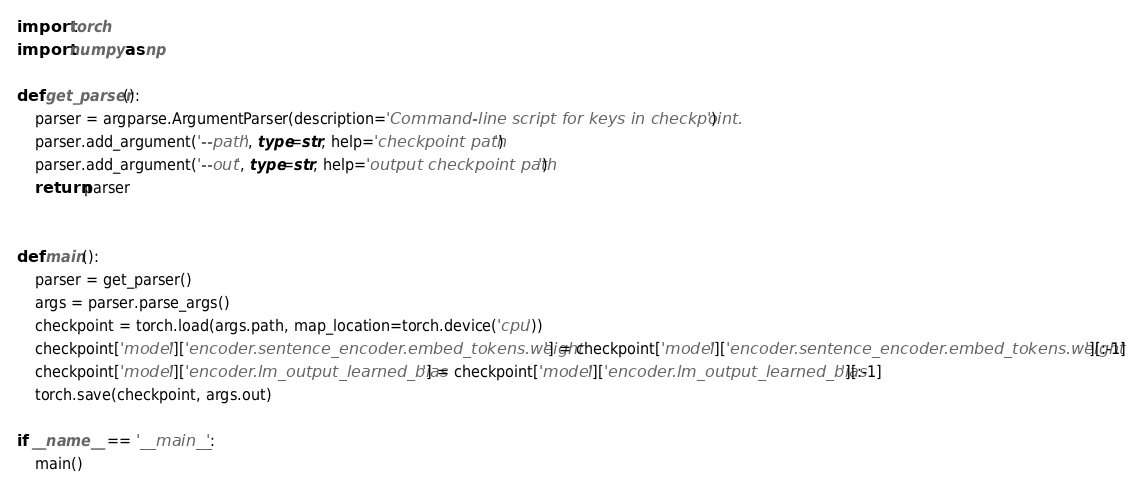Convert code to text. <code><loc_0><loc_0><loc_500><loc_500><_Python_>import torch 
import numpy as np

def get_parser():
    parser = argparse.ArgumentParser(description='Command-line script for keys in checkpoint.')
    parser.add_argument('--path', type=str, help='checkpoint path')
    parser.add_argument('--out', type=str, help='output checkpoint path')
    return parser


def main():
    parser = get_parser()
    args = parser.parse_args()
    checkpoint = torch.load(args.path, map_location=torch.device('cpu'))
    checkpoint['model']['encoder.sentence_encoder.embed_tokens.weight'] = checkpoint['model']['encoder.sentence_encoder.embed_tokens.weight'][:-1]
    checkpoint['model']['encoder.lm_output_learned_bias'] = checkpoint['model']['encoder.lm_output_learned_bias'][:-1]
    torch.save(checkpoint, args.out)

if __name__ == '__main__':
    main()
</code> 